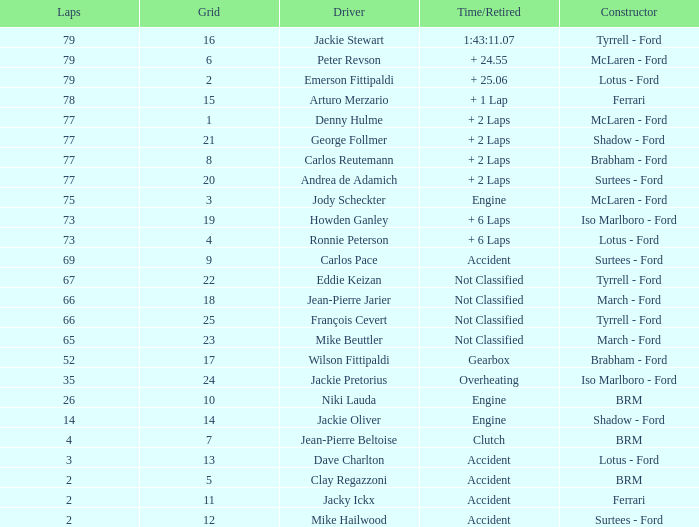How much time is required for less than 35 laps and less than 10 grids? Clutch, Accident. 